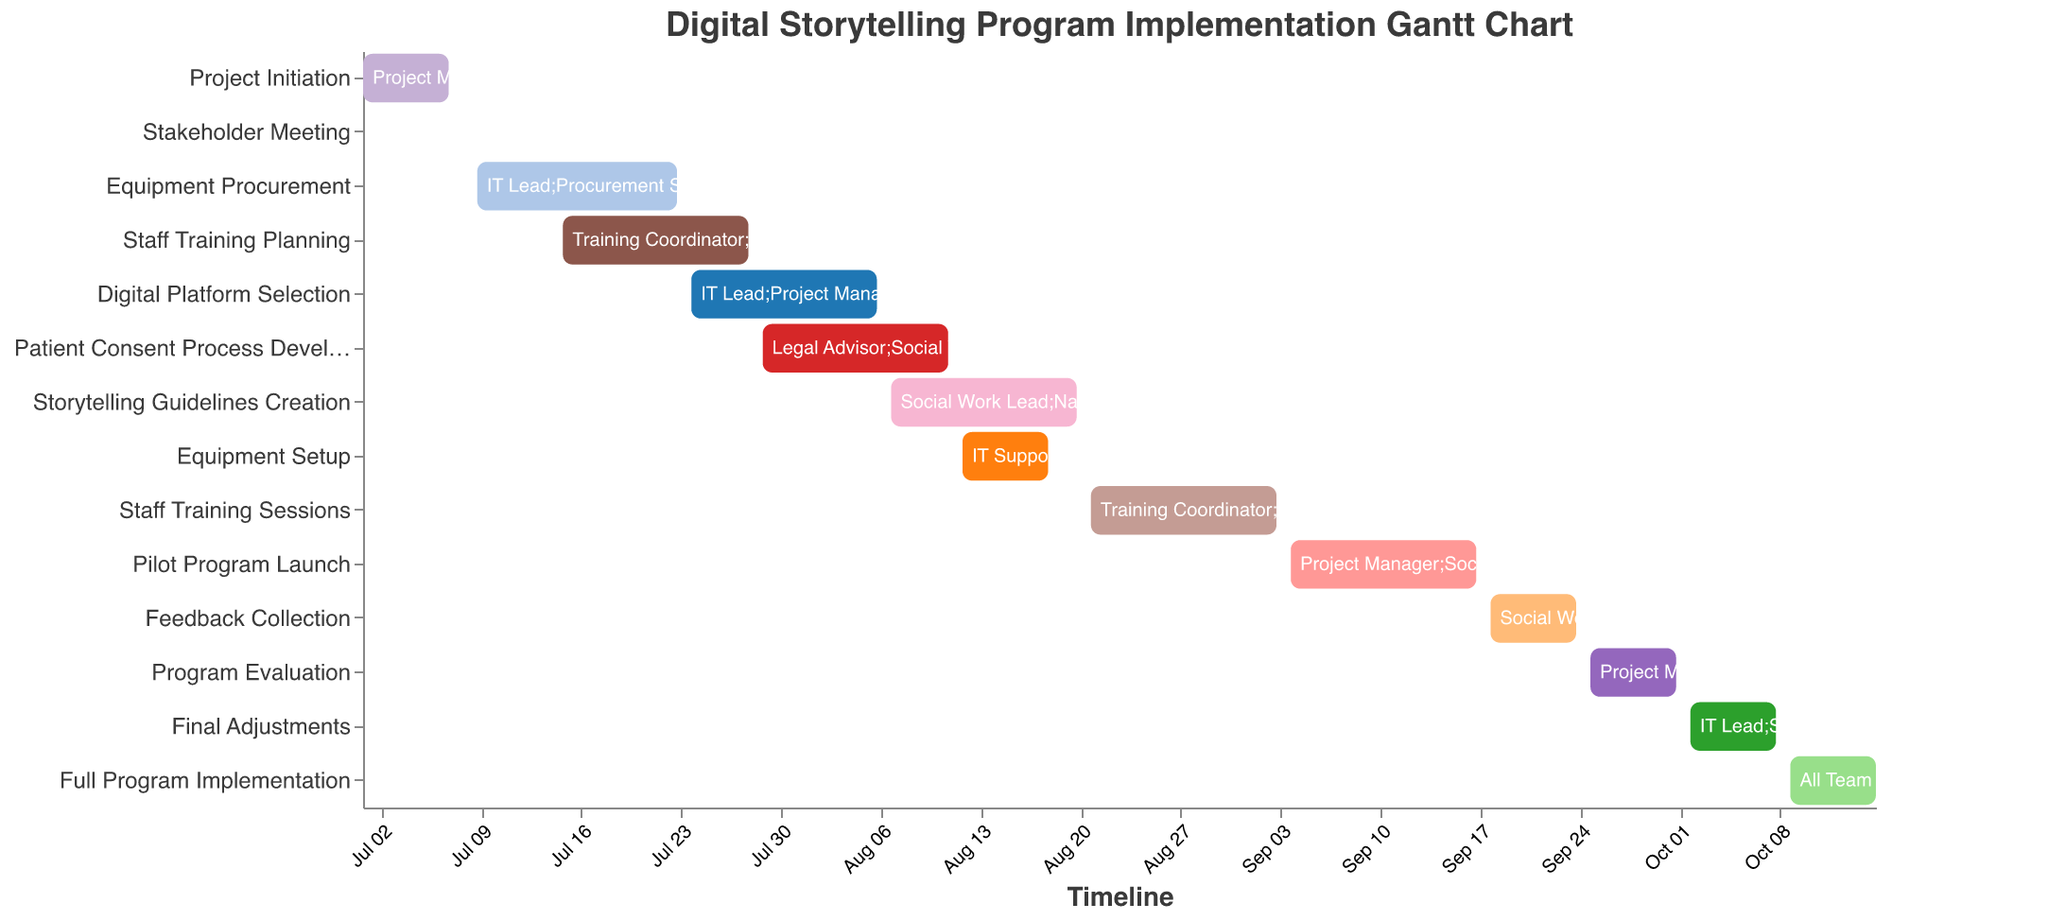What is the title of the Gantt chart? The title is displayed at the top of the chart.
Answer: Digital Storytelling Program Implementation Gantt Chart Which task has the shortest duration? Identify the task with the smallest time span between the start and end dates. Stakeholder Meeting only spans one day.
Answer: Stakeholder Meeting Which tasks require the involvement of the Social Work Lead? Look for all tasks that list the Social Work Lead as a resource.
Answer: Staff Training Planning, Patient Consent Process Development, Storytelling Guidelines Creation, Pilot Program Launch, Feedback Collection, Program Evaluation, Final Adjustments, Full Program Implementation When does the Staff Training Planning task start and end? Refer to the Gantt bar corresponding to "Staff Training Planning" to find its start and end dates.
Answer: July 15 to July 28 How many tasks are there in total? Count the number of distinct tasks listed in the chart.
Answer: 14 Which task has the longest duration? Calculate the duration for each task and find the one with the highest value. "Equipment Procurement" spans from July 9 to July 23, a total of 15 days, which is the longest.
Answer: Equipment Procurement Are any tasks scheduled with overlapping dates? Examine the start and end dates of each task to see where overlaps occur. For example, "Equipment Procurement" and "Staff Training Planning" overlap between July 15 and July 23.
Answer: Yes Which tasks are completed by October 15, 2023? Look for tasks ending on or before October 15.
Answer: All tasks Does the Patient Consent Process Development task extend into the same time period as the Digital Platform Selection task? Compare the start and end dates of both tasks to see if there’s any overlap. Both tasks overlap from July 29 to August 6.
Answer: Yes During what period is the Full Program Implementation scheduled to occur? Refer to the start and end dates for the "Full Program Implementation" task.
Answer: October 9 to October 15 